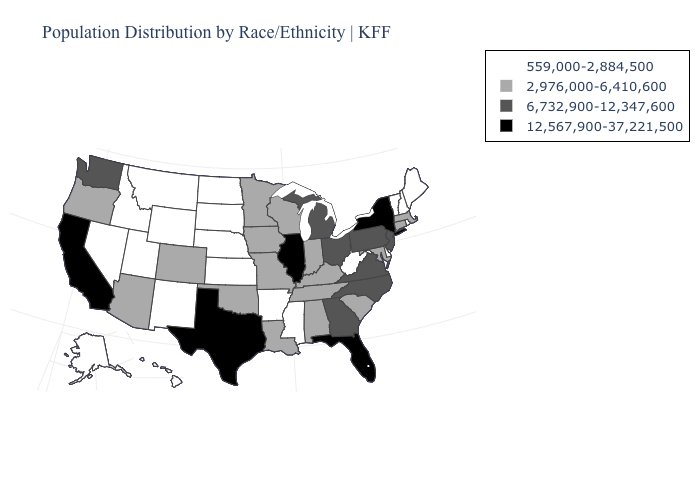What is the value of West Virginia?
Answer briefly. 559,000-2,884,500. What is the value of Georgia?
Short answer required. 6,732,900-12,347,600. Does Michigan have the highest value in the MidWest?
Give a very brief answer. No. What is the value of New York?
Write a very short answer. 12,567,900-37,221,500. Name the states that have a value in the range 559,000-2,884,500?
Give a very brief answer. Alaska, Arkansas, Delaware, Hawaii, Idaho, Kansas, Maine, Mississippi, Montana, Nebraska, Nevada, New Hampshire, New Mexico, North Dakota, Rhode Island, South Dakota, Utah, Vermont, West Virginia, Wyoming. Name the states that have a value in the range 6,732,900-12,347,600?
Short answer required. Georgia, Michigan, New Jersey, North Carolina, Ohio, Pennsylvania, Virginia, Washington. What is the value of Mississippi?
Answer briefly. 559,000-2,884,500. Which states have the highest value in the USA?
Write a very short answer. California, Florida, Illinois, New York, Texas. Which states have the highest value in the USA?
Short answer required. California, Florida, Illinois, New York, Texas. Name the states that have a value in the range 6,732,900-12,347,600?
Concise answer only. Georgia, Michigan, New Jersey, North Carolina, Ohio, Pennsylvania, Virginia, Washington. Does Nebraska have a lower value than Massachusetts?
Short answer required. Yes. Among the states that border Arkansas , which have the lowest value?
Concise answer only. Mississippi. Name the states that have a value in the range 6,732,900-12,347,600?
Be succinct. Georgia, Michigan, New Jersey, North Carolina, Ohio, Pennsylvania, Virginia, Washington. Name the states that have a value in the range 559,000-2,884,500?
Write a very short answer. Alaska, Arkansas, Delaware, Hawaii, Idaho, Kansas, Maine, Mississippi, Montana, Nebraska, Nevada, New Hampshire, New Mexico, North Dakota, Rhode Island, South Dakota, Utah, Vermont, West Virginia, Wyoming. What is the value of New Hampshire?
Quick response, please. 559,000-2,884,500. 